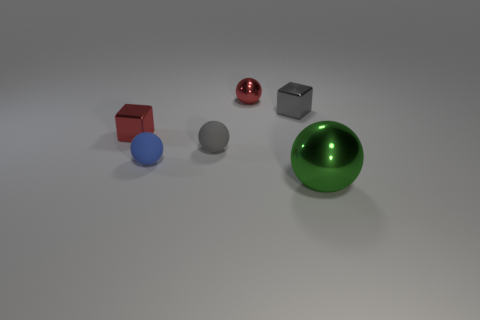The other matte thing that is the same size as the blue thing is what color?
Your answer should be very brief. Gray. What number of small things are either green objects or yellow cubes?
Ensure brevity in your answer.  0. Are there an equal number of red balls in front of the blue ball and red shiny blocks behind the tiny gray block?
Provide a succinct answer. Yes. What number of gray cubes are the same size as the red cube?
Make the answer very short. 1. What number of gray things are either blocks or tiny balls?
Offer a very short reply. 2. Are there an equal number of tiny red blocks that are to the right of the tiny gray cube and large yellow shiny cubes?
Your response must be concise. Yes. What is the size of the green object that is in front of the gray sphere?
Offer a very short reply. Large. What number of small blue things have the same shape as the large metallic thing?
Ensure brevity in your answer.  1. What is the object that is both to the right of the red metallic sphere and behind the large green ball made of?
Give a very brief answer. Metal. Are the green ball and the tiny red ball made of the same material?
Provide a short and direct response. Yes. 